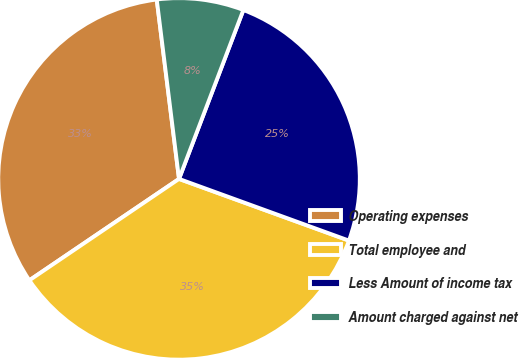<chart> <loc_0><loc_0><loc_500><loc_500><pie_chart><fcel>Operating expenses<fcel>Total employee and<fcel>Less Amount of income tax<fcel>Amount charged against net<nl><fcel>32.51%<fcel>34.98%<fcel>24.75%<fcel>7.76%<nl></chart> 